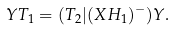<formula> <loc_0><loc_0><loc_500><loc_500>Y T _ { 1 } = ( T _ { 2 } | ( X H _ { 1 } ) ^ { - } ) Y .</formula> 